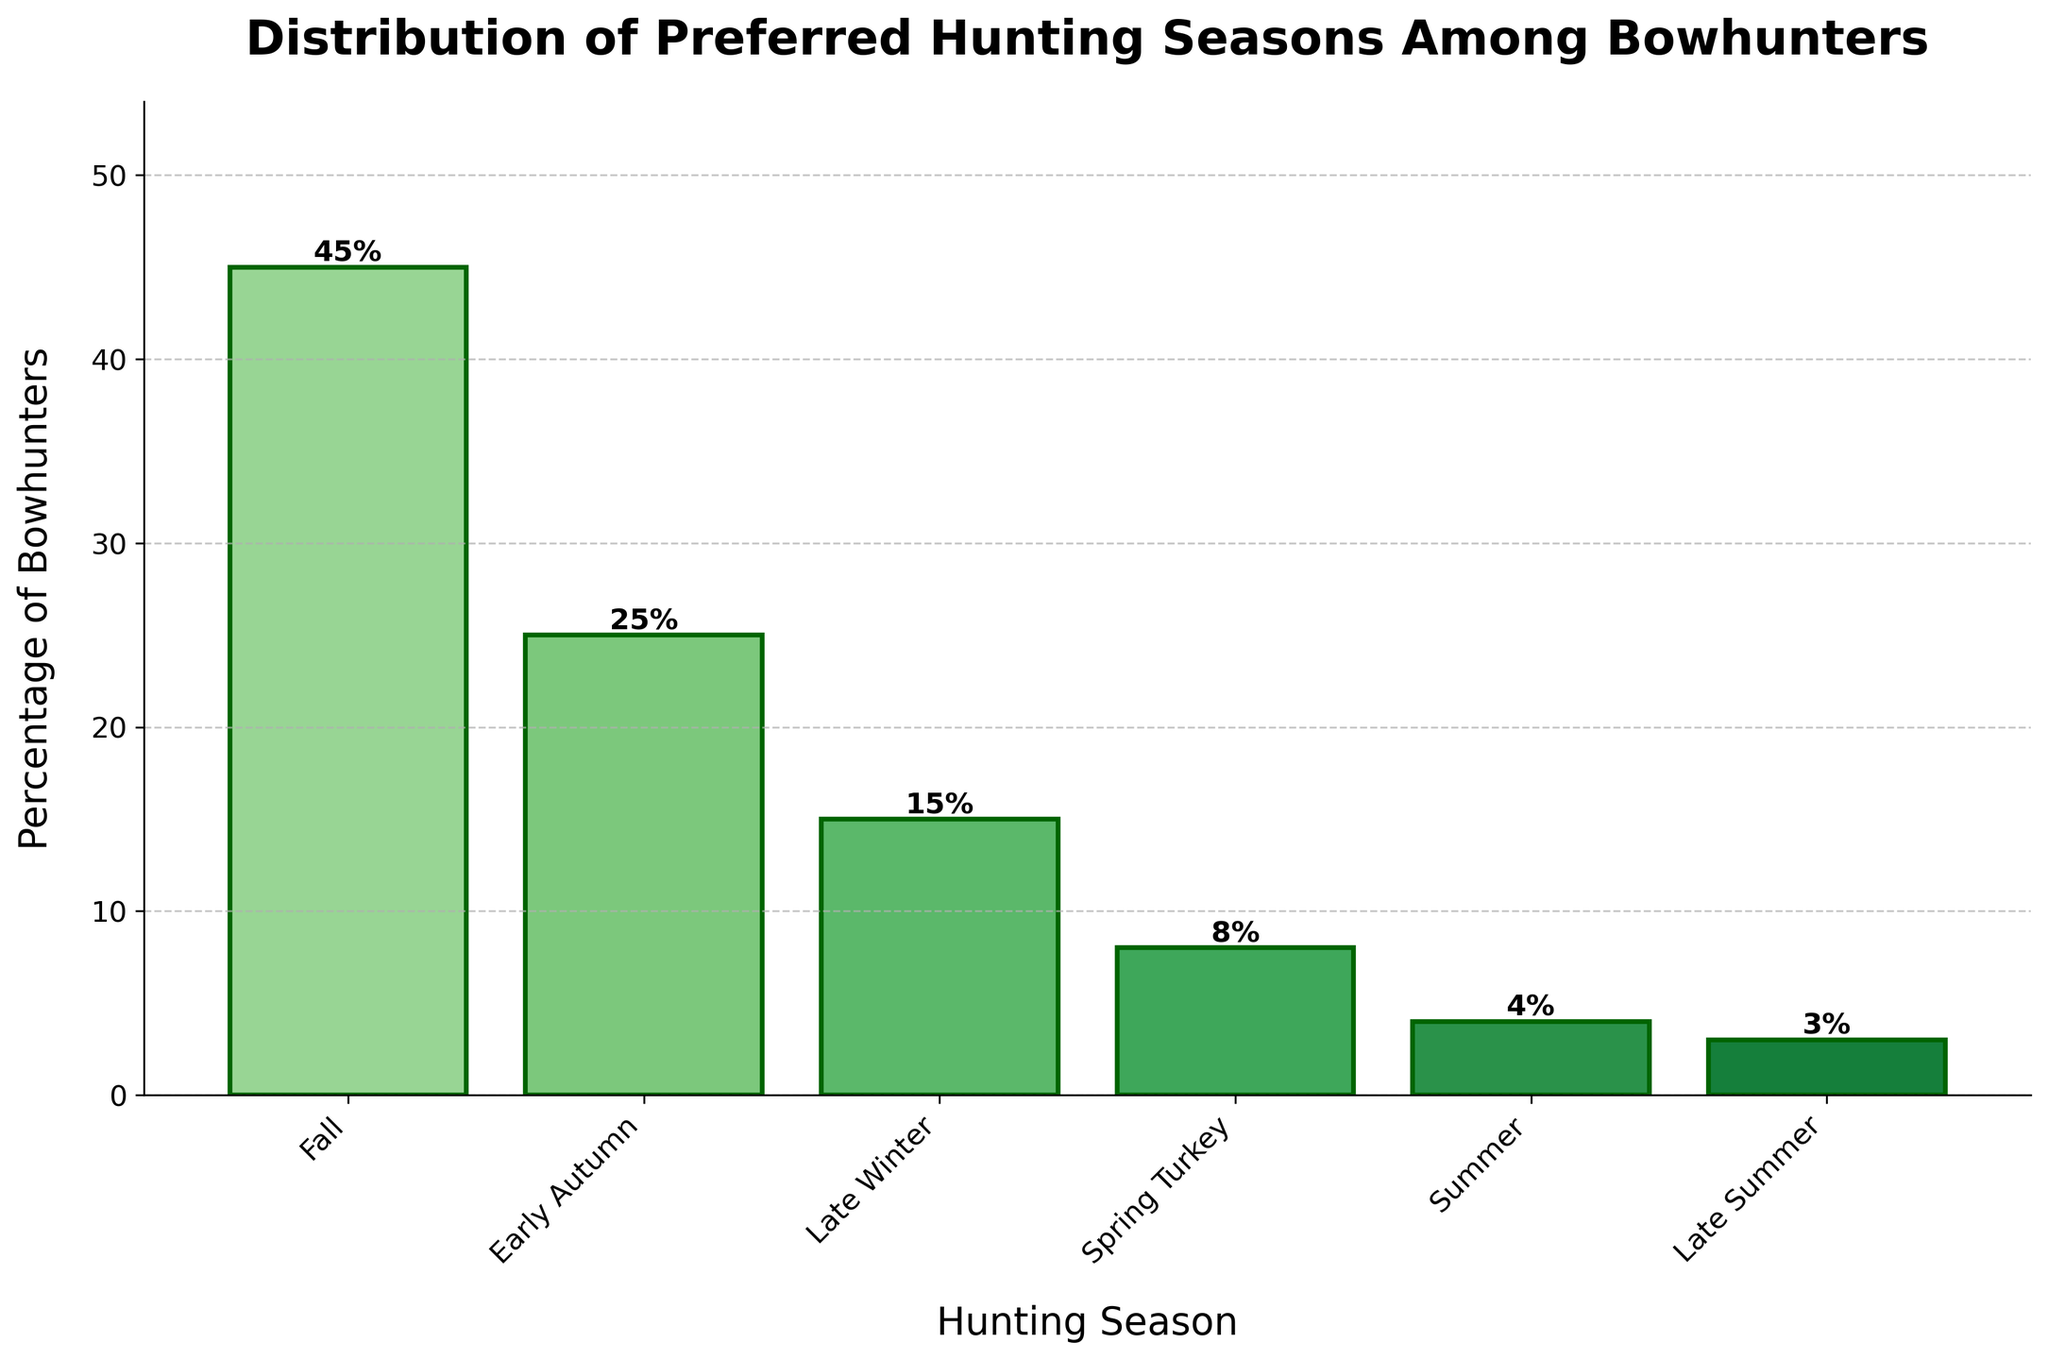Which hunting season is preferred by the most bowhunters? Look at the bar chart, identify the bar with the highest percentage. Fall has the tallest bar, indicating it is preferred by the highest percentage of bowhunters at 45%.
Answer: Fall What is the sum of percentages for Fall and Early Autumn? Identify the percentages for Fall and Early Autumn from the chart (45% and 25% respectively). Add these percentages: 45% + 25% = 70%.
Answer: 70% Which two hunting seasons have the smallest percentages of bowhunters preferring them? Look at the bars for the smallest percentages. The two seasons with the smallest bars are Late Summer and Summer at 3% and 4% respectively.
Answer: Late Summer and Summer How much taller is the bar for Late Winter compared to Spring Turkey? Identify the percentages from the bars corresponding to Late Winter and Spring Turkey. Late Winter is 15% and Spring Turkey is 8%. Find the difference: 15% - 8% = 7%.
Answer: 7% What is the average percentage of bowhunters who prefer Late Winter, Spring Turkey, and Summer? Identify the percentages: Late Winter (15%), Spring Turkey (8%), and Summer (4%). Find the average: (15 + 8 + 4) / 3 = 27 / 3 = 9%.
Answer: 9% By how much does the percentage of bowhunters preferring Fall exceed that of Early Autumn? Determine the percentages: Fall (45%) and Early Autumn (25%). Calculate the difference: 45% - 25% = 20%.
Answer: 20% Which hunting season has a percentage exactly half that of Early Autumn? The percentage for Early Autumn is 25%. Half of 25% is 12.5%, but the closest bar to this value in the chart is Spring Turkey at 8%. Hence, no season exactly matches half of Early Autumn.
Answer: None What's the combined percentage for the seasons that have less than 10% preference? Identify the seasons with less than 10%: Spring Turkey (8%), Summer (4%), and Late Summer (3%). Sum these percentages: 8% + 4% + 3% = 15%.
Answer: 15% Which season has a preference closest to 10% and is it above or below 10%? The closest percentages to 10% in the chart are Spring Turkey (8%) and Late Winter (15%). 8% is the closest, and it is below 10%.
Answer: Spring Turkey, below 